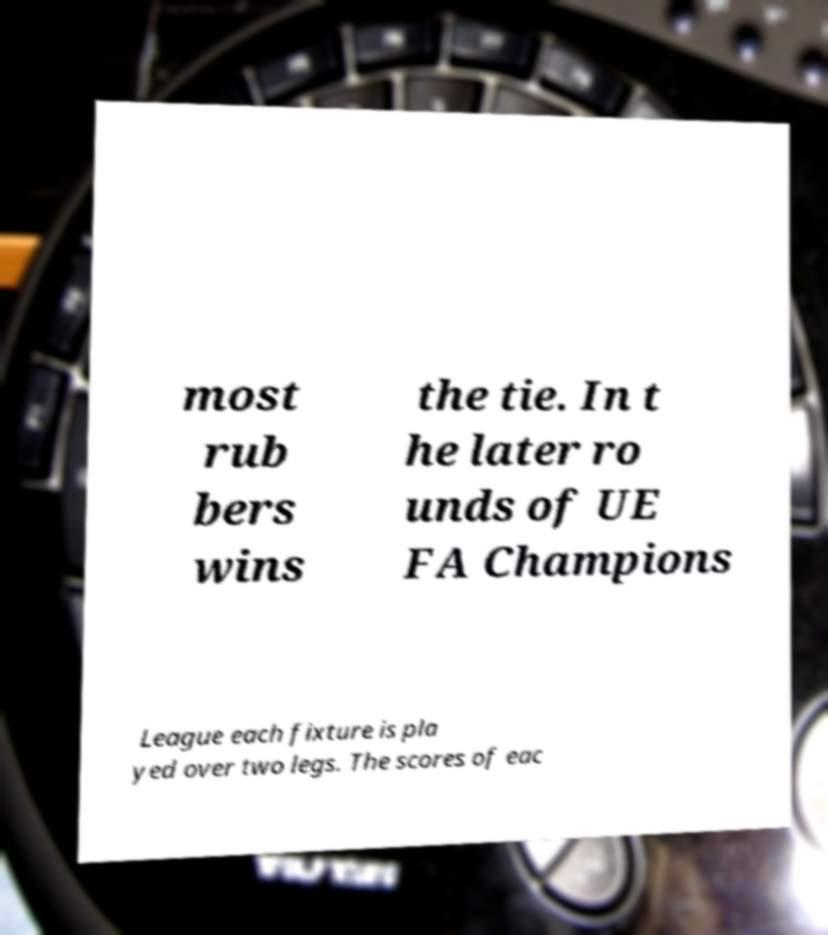Please read and relay the text visible in this image. What does it say? most rub bers wins the tie. In t he later ro unds of UE FA Champions League each fixture is pla yed over two legs. The scores of eac 